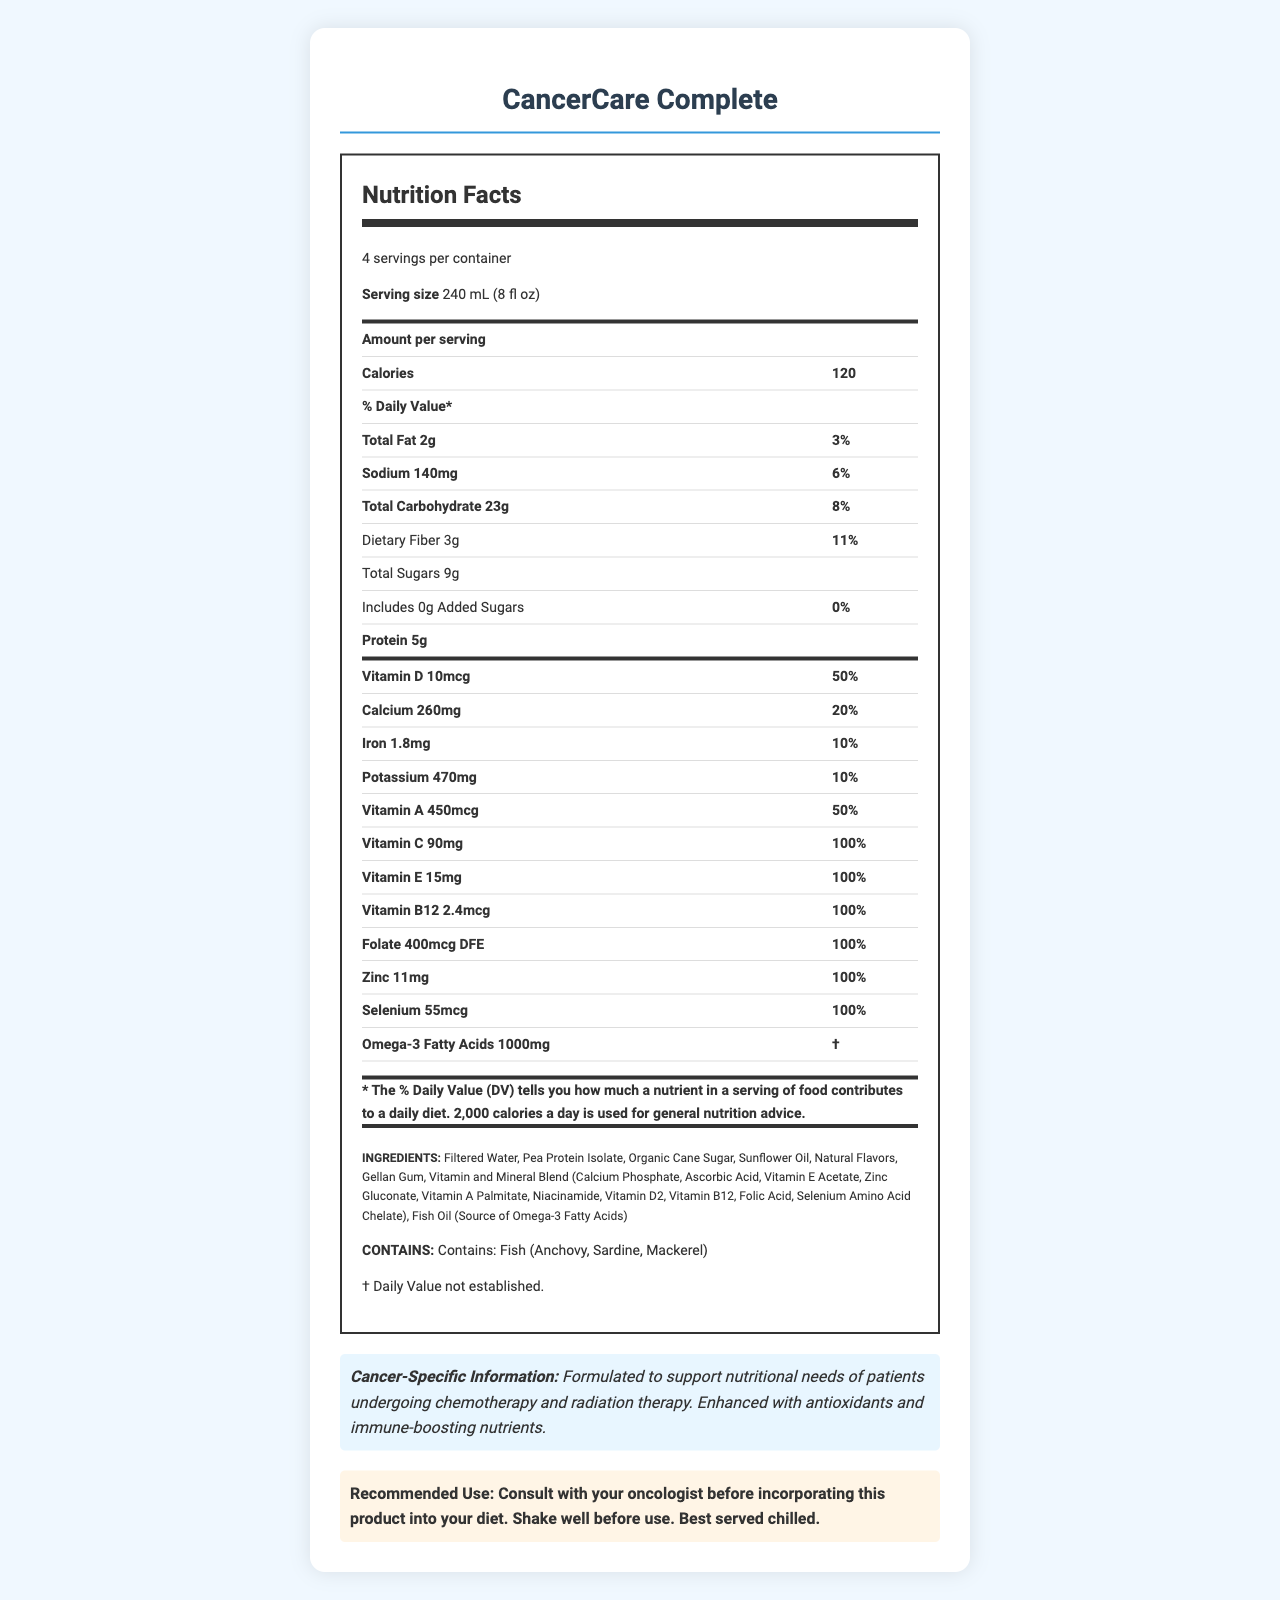What is the serving size for CancerCare Complete? The serving size is clearly indicated on the Nutrition Facts Label as 240 mL (8 fl oz).
Answer: 240 mL (8 fl oz) How many calories does one serving of CancerCare Complete have? The amount of calories per serving is stated as 120 calories on the Nutrition Facts Label.
Answer: 120 calories What is the amount of protein per serving in CancerCare Complete? The Nutrition Facts Label lists the protein content as 5g per serving.
Answer: 5g List four vitamins included in CancerCare Complete along with their daily value percentages. These vitamins and their daily value percentages are listed in the Nutrition Facts Label.
Answer: Vitamin D 50%, Vitamin A 50%, Vitamin C 100%, Vitamin E 100% What is the daily value percentage for dietary fiber in CancerCare Complete? The daily value percentage for dietary fiber is given as 11% on the Nutrition Facts Label.
Answer: 11% Which of the following allergens does CancerCare Complete contain? A. Dairy B. Gluten C. Fish The allergen information lists fish as an allergen, specifying anchovy, sardine, and mackerel.
Answer: C. Fish What is the total carbohydrate content per serving of CancerCare Complete? A. 11g B. 23g C. 8g D. 50g The Nutrition Facts Label states that each serving contains 23g of total carbohydrates.
Answer: B. 23g Does CancerCare Complete contain any added sugars? The Nutrition Facts Label indicates that there are 0g of added sugars.
Answer: No Summarize the main purpose of CancerCare Complete. The document repeatedly highlights the product's aim to support cancer patients' nutritional needs, particularly those undergoing treatment.
Answer: CancerCare Complete is designed to support the nutritional needs of patients undergoing chemotherapy and radiation therapy, with an emphasis on antioxidants and immune-boosting nutrients. What is the main ingredient in CancerCare Complete? The ingredient list starts with Filtered Water, indicating it is the main ingredient by volume.
Answer: Filtered Water How much iron does one serving of CancerCare Complete provide? The iron content per serving is listed as 1.8mg on the Nutrition Facts Label.
Answer: 1.8mg What advice is given regarding the consumption of CancerCare Complete? The Recommended Use section provides this advice, ensuring patients consult their oncologist and specifying how to best consume the beverage.
Answer: Consult with your oncologist before incorporating this product into your diet. Shake well before use. Best served chilled. Can we determine the exact fish oil source's daily value percentage for omega-3 fatty acids? The document specifies that the daily value for omega-3 fatty acids is not established, thus this information is not available.
Answer: No What is the amount of calcium per serving, and how does it compare to the daily value percentage? The Nutrition Facts Label indicates that one serving contains 260mg of calcium, contributing to 20% of the daily value.
Answer: 260mg, 20% Identify an antioxidant present in CancerCare Complete and its daily value percentage. Vitamin C is listed as an antioxidant with a daily value percentage of 100% on the Nutrition Facts Label.
Answer: Vitamin C, 100% What specific types of fish does the allergen information mention? The allergen information section lists these specific types of fish.
Answer: Anchovy, Sardine, Mackerel 